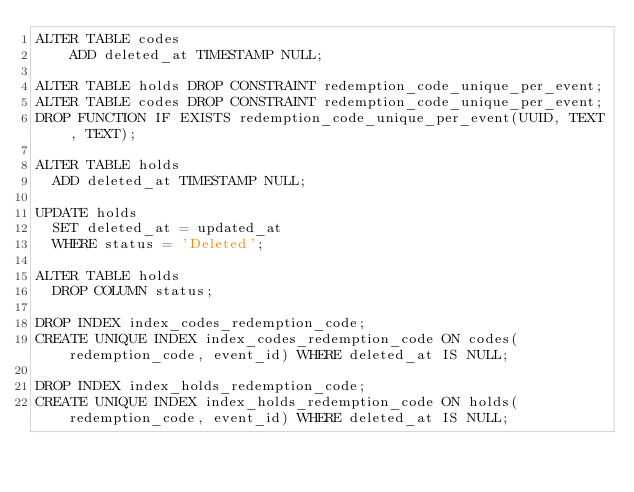Convert code to text. <code><loc_0><loc_0><loc_500><loc_500><_SQL_>ALTER TABLE codes
    ADD deleted_at TIMESTAMP NULL;

ALTER TABLE holds DROP CONSTRAINT redemption_code_unique_per_event;
ALTER TABLE codes DROP CONSTRAINT redemption_code_unique_per_event;
DROP FUNCTION IF EXISTS redemption_code_unique_per_event(UUID, TEXT, TEXT);

ALTER TABLE holds
  ADD deleted_at TIMESTAMP NULL;

UPDATE holds
  SET deleted_at = updated_at
  WHERE status = 'Deleted';

ALTER TABLE holds
  DROP COLUMN status;

DROP INDEX index_codes_redemption_code;
CREATE UNIQUE INDEX index_codes_redemption_code ON codes(redemption_code, event_id) WHERE deleted_at IS NULL;

DROP INDEX index_holds_redemption_code;
CREATE UNIQUE INDEX index_holds_redemption_code ON holds(redemption_code, event_id) WHERE deleted_at IS NULL;

</code> 